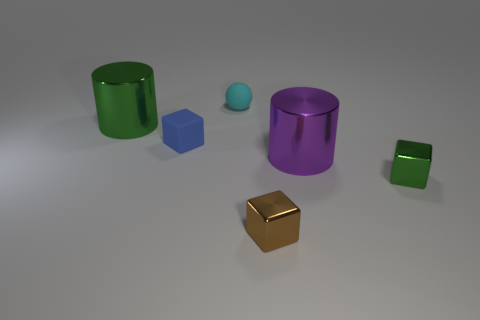There is a rubber thing that is in front of the cyan matte sphere; is it the same shape as the brown object?
Your answer should be compact. Yes. How many objects are cylinders that are left of the tiny cyan object or small green objects on the right side of the cyan rubber ball?
Keep it short and to the point. 2. There is another tiny rubber thing that is the same shape as the tiny green thing; what is its color?
Offer a very short reply. Blue. Are there any other things that are the same shape as the cyan thing?
Ensure brevity in your answer.  No. Do the small brown object and the green metallic thing in front of the tiny blue matte block have the same shape?
Make the answer very short. Yes. What is the material of the blue object?
Offer a very short reply. Rubber. There is another metallic object that is the same shape as the small green metal object; what is its size?
Give a very brief answer. Small. How many other things are there of the same material as the green cylinder?
Give a very brief answer. 3. Do the green block and the big cylinder in front of the large green cylinder have the same material?
Keep it short and to the point. Yes. Are there fewer green metal things on the left side of the blue thing than large objects that are behind the brown metallic object?
Offer a terse response. Yes. 